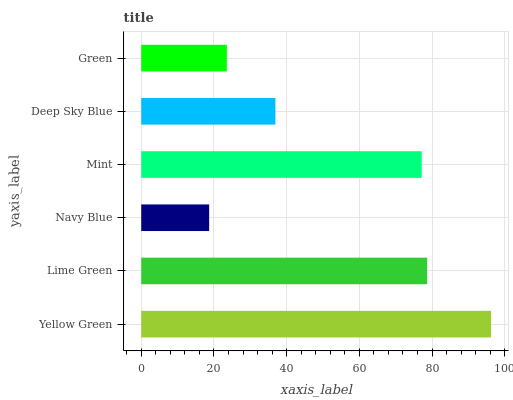Is Navy Blue the minimum?
Answer yes or no. Yes. Is Yellow Green the maximum?
Answer yes or no. Yes. Is Lime Green the minimum?
Answer yes or no. No. Is Lime Green the maximum?
Answer yes or no. No. Is Yellow Green greater than Lime Green?
Answer yes or no. Yes. Is Lime Green less than Yellow Green?
Answer yes or no. Yes. Is Lime Green greater than Yellow Green?
Answer yes or no. No. Is Yellow Green less than Lime Green?
Answer yes or no. No. Is Mint the high median?
Answer yes or no. Yes. Is Deep Sky Blue the low median?
Answer yes or no. Yes. Is Green the high median?
Answer yes or no. No. Is Green the low median?
Answer yes or no. No. 